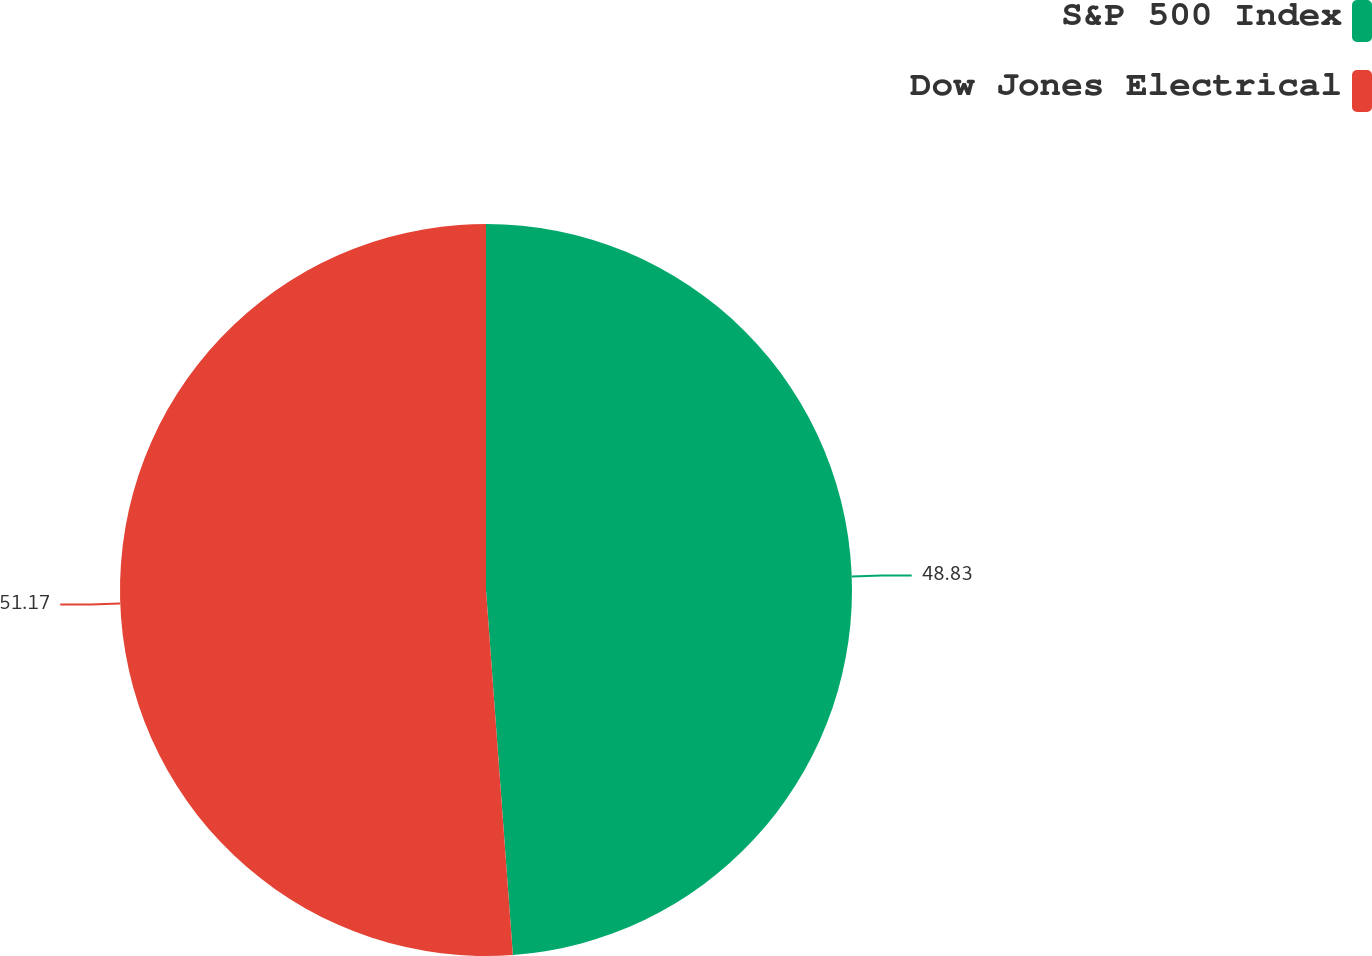<chart> <loc_0><loc_0><loc_500><loc_500><pie_chart><fcel>S&P 500 Index<fcel>Dow Jones Electrical<nl><fcel>48.83%<fcel>51.17%<nl></chart> 